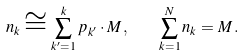Convert formula to latex. <formula><loc_0><loc_0><loc_500><loc_500>n _ { k } \cong \sum _ { k ^ { \prime } = 1 } ^ { k } p _ { k ^ { \prime } } \cdot M \, , \quad \sum _ { k = 1 } ^ { N } n _ { k } = M \, .</formula> 